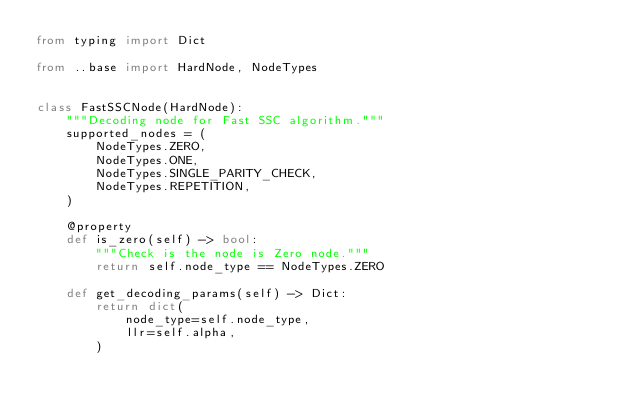Convert code to text. <code><loc_0><loc_0><loc_500><loc_500><_Python_>from typing import Dict

from ..base import HardNode, NodeTypes


class FastSSCNode(HardNode):
    """Decoding node for Fast SSC algorithm."""
    supported_nodes = (
        NodeTypes.ZERO,
        NodeTypes.ONE,
        NodeTypes.SINGLE_PARITY_CHECK,
        NodeTypes.REPETITION,
    )

    @property
    def is_zero(self) -> bool:
        """Check is the node is Zero node."""
        return self.node_type == NodeTypes.ZERO

    def get_decoding_params(self) -> Dict:
        return dict(
            node_type=self.node_type,
            llr=self.alpha,
        )
</code> 